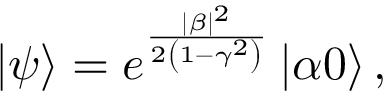Convert formula to latex. <formula><loc_0><loc_0><loc_500><loc_500>\left | \psi \right \rangle = e ^ { \frac { | \beta | ^ { 2 } } { 2 \left ( 1 - \gamma ^ { 2 } \right ) } } \left | \alpha 0 \right \rangle ,</formula> 